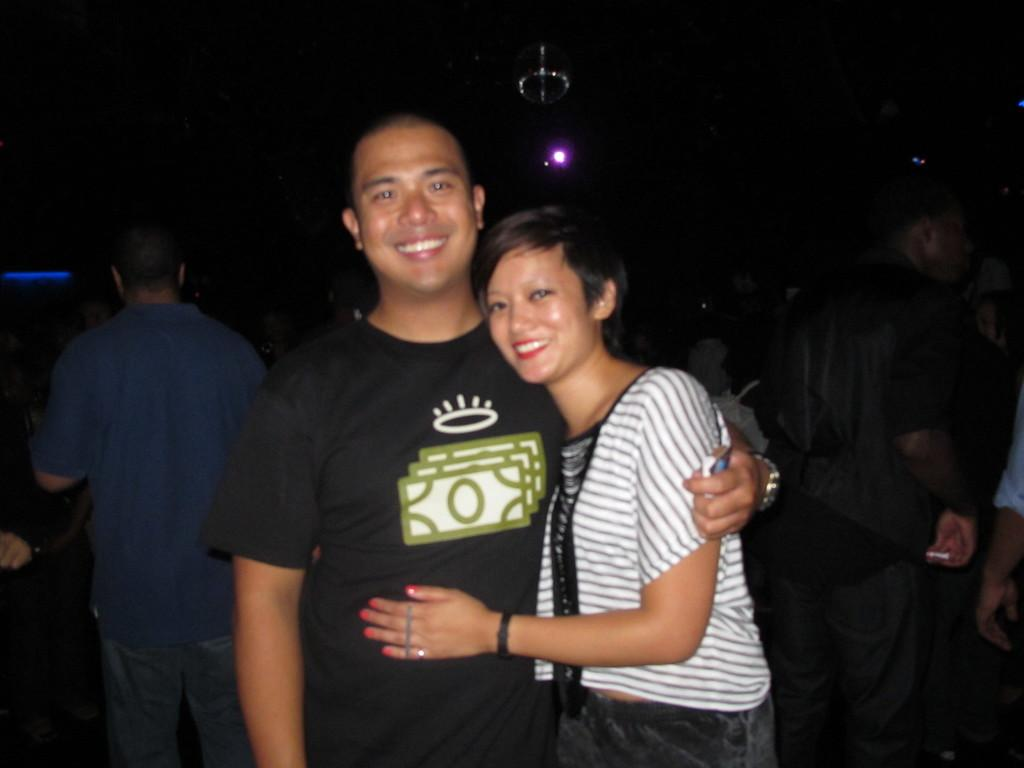What is the main subject of the image? The main subject of the image is groups of people standing. Can you describe the light at the top of the image? Yes, there is a light at the top of the image. How many teeth can be seen in the image? There are no teeth visible in the image. What type of balls are being used by the maid in the image? There is no maid or balls present in the image. 